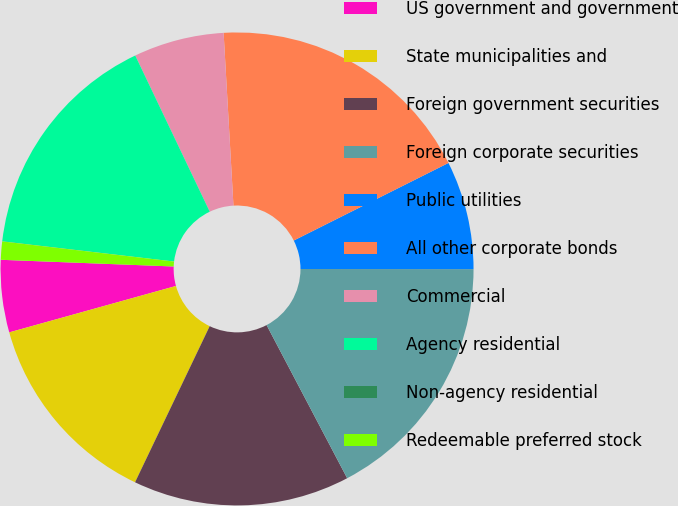Convert chart to OTSL. <chart><loc_0><loc_0><loc_500><loc_500><pie_chart><fcel>US government and government<fcel>State municipalities and<fcel>Foreign government securities<fcel>Foreign corporate securities<fcel>Public utilities<fcel>All other corporate bonds<fcel>Commercial<fcel>Agency residential<fcel>Non-agency residential<fcel>Redeemable preferred stock<nl><fcel>4.94%<fcel>13.58%<fcel>14.81%<fcel>17.28%<fcel>7.41%<fcel>18.51%<fcel>6.18%<fcel>16.05%<fcel>0.01%<fcel>1.24%<nl></chart> 